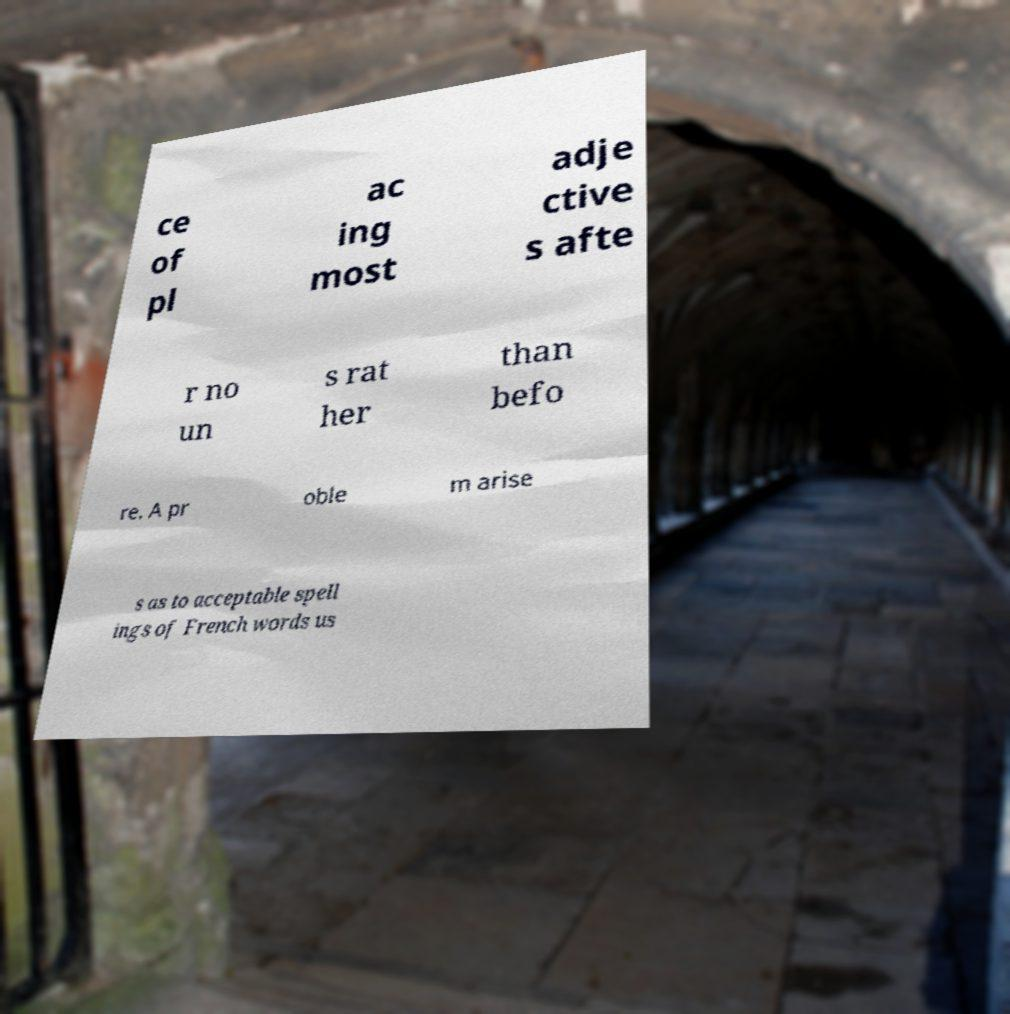Can you read and provide the text displayed in the image?This photo seems to have some interesting text. Can you extract and type it out for me? ce of pl ac ing most adje ctive s afte r no un s rat her than befo re. A pr oble m arise s as to acceptable spell ings of French words us 